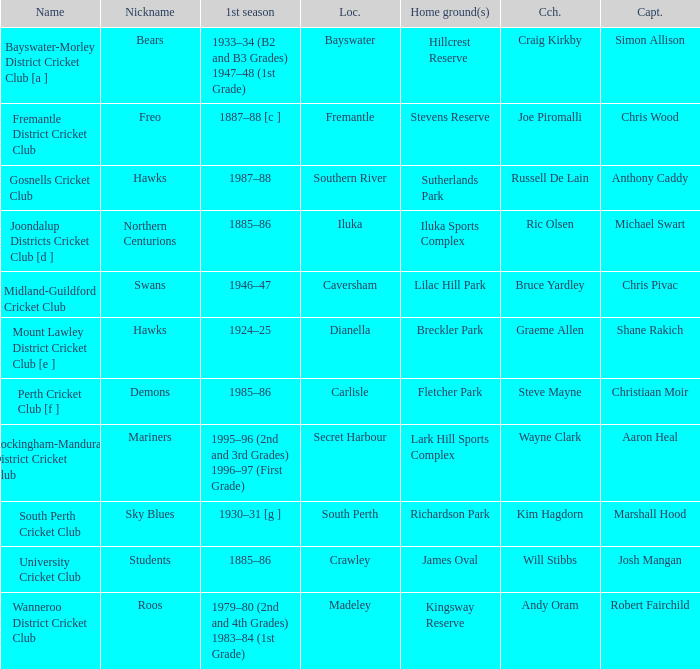What is the location for the club with the nickname the bears? Bayswater. 